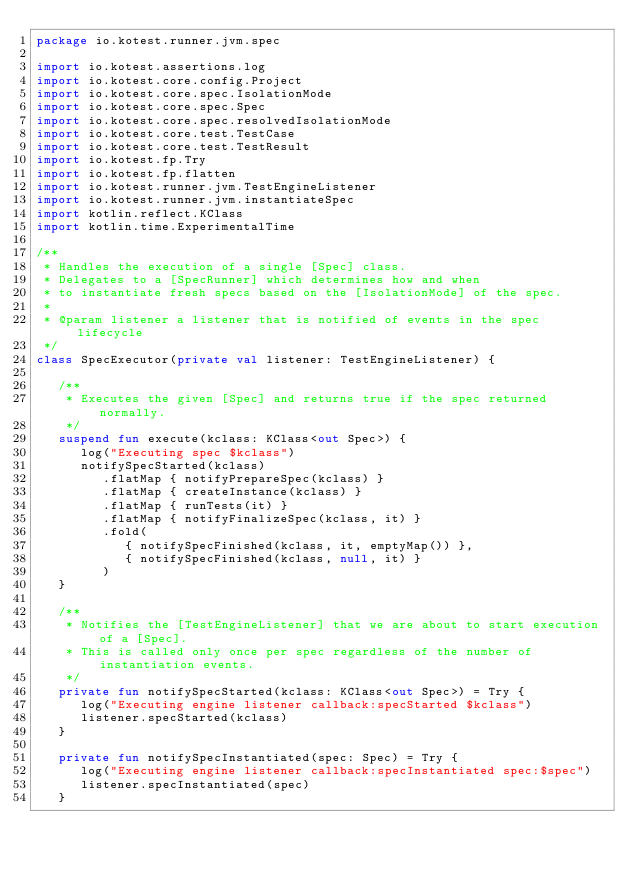<code> <loc_0><loc_0><loc_500><loc_500><_Kotlin_>package io.kotest.runner.jvm.spec

import io.kotest.assertions.log
import io.kotest.core.config.Project
import io.kotest.core.spec.IsolationMode
import io.kotest.core.spec.Spec
import io.kotest.core.spec.resolvedIsolationMode
import io.kotest.core.test.TestCase
import io.kotest.core.test.TestResult
import io.kotest.fp.Try
import io.kotest.fp.flatten
import io.kotest.runner.jvm.TestEngineListener
import io.kotest.runner.jvm.instantiateSpec
import kotlin.reflect.KClass
import kotlin.time.ExperimentalTime

/**
 * Handles the execution of a single [Spec] class.
 * Delegates to a [SpecRunner] which determines how and when
 * to instantiate fresh specs based on the [IsolationMode] of the spec.
 *
 * @param listener a listener that is notified of events in the spec lifecycle
 */
class SpecExecutor(private val listener: TestEngineListener) {

   /**
    * Executes the given [Spec] and returns true if the spec returned normally.
    */
   suspend fun execute(kclass: KClass<out Spec>) {
      log("Executing spec $kclass")
      notifySpecStarted(kclass)
         .flatMap { notifyPrepareSpec(kclass) }
         .flatMap { createInstance(kclass) }
         .flatMap { runTests(it) }
         .flatMap { notifyFinalizeSpec(kclass, it) }
         .fold(
            { notifySpecFinished(kclass, it, emptyMap()) },
            { notifySpecFinished(kclass, null, it) }
         )
   }

   /**
    * Notifies the [TestEngineListener] that we are about to start execution of a [Spec].
    * This is called only once per spec regardless of the number of instantiation events.
    */
   private fun notifySpecStarted(kclass: KClass<out Spec>) = Try {
      log("Executing engine listener callback:specStarted $kclass")
      listener.specStarted(kclass)
   }

   private fun notifySpecInstantiated(spec: Spec) = Try {
      log("Executing engine listener callback:specInstantiated spec:$spec")
      listener.specInstantiated(spec)
   }
</code> 